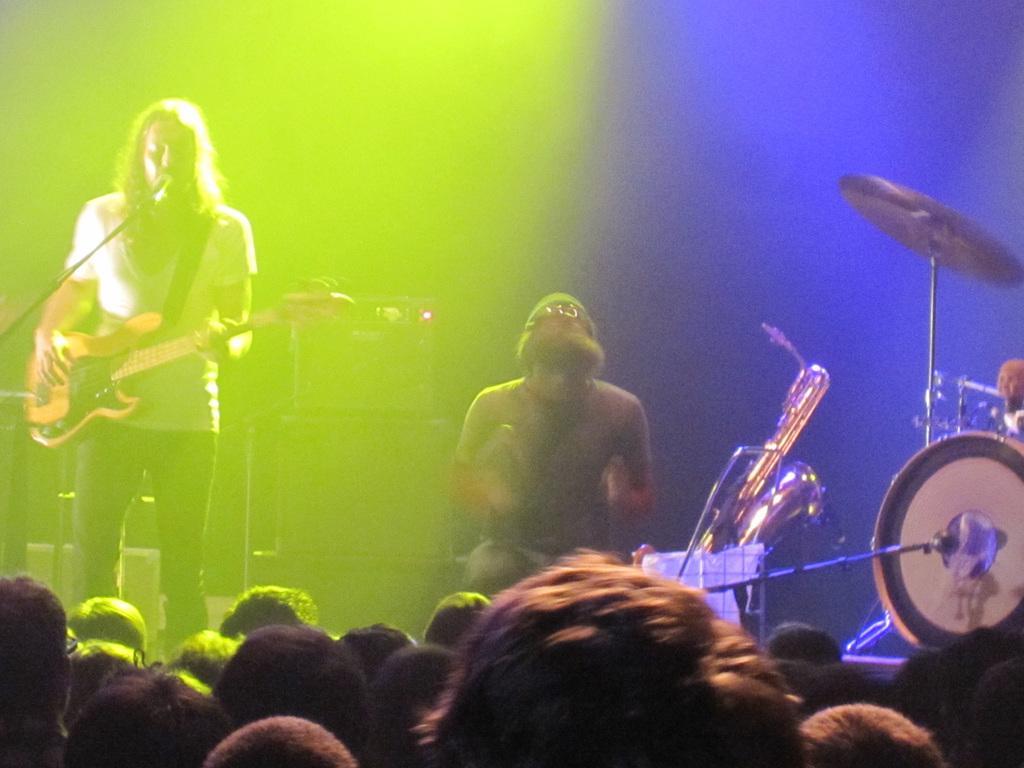Can you describe this image briefly? The picture is taken on the stage where at the left corner one person is standing in white shirt and playing a guitar and singing song in front of microphone and another person is sitting and there are some musical instruments and drums and in front of them there is crowd. 